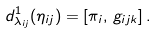Convert formula to latex. <formula><loc_0><loc_0><loc_500><loc_500>d ^ { 1 } _ { \lambda _ { i j } } ( \eta _ { i j } ) = [ \pi _ { i } , \, g _ { i j k } ] \, .</formula> 